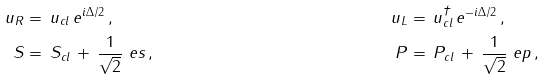<formula> <loc_0><loc_0><loc_500><loc_500>u _ { R } & = \, u _ { c l } \, e ^ { i \Delta / 2 } \, , & u _ { L } & = \, u _ { c l } ^ { \dagger } \, e ^ { - i \Delta / 2 } \, , \\ S & = \, S _ { c l } \, + \, \frac { 1 } { \sqrt { 2 } } { \ e s } \, , & P & = \, P _ { c l } \, + \, \frac { 1 } { \sqrt { 2 } } { \ e p } \, ,</formula> 